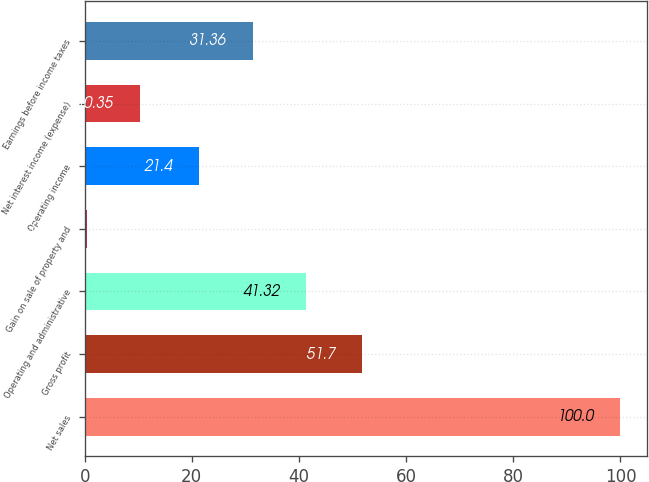Convert chart to OTSL. <chart><loc_0><loc_0><loc_500><loc_500><bar_chart><fcel>Net sales<fcel>Gross profit<fcel>Operating and administrative<fcel>Gain on sale of property and<fcel>Operating income<fcel>Net interest income (expense)<fcel>Earnings before income taxes<nl><fcel>100<fcel>51.7<fcel>41.32<fcel>0.39<fcel>21.4<fcel>10.35<fcel>31.36<nl></chart> 